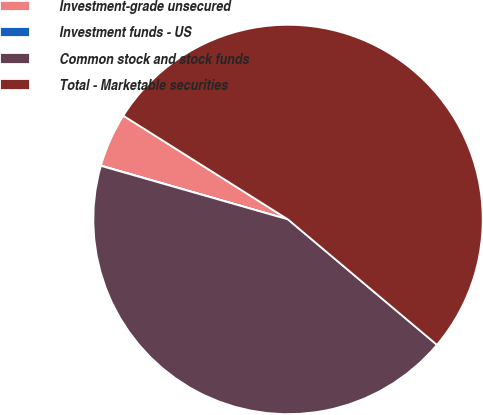<chart> <loc_0><loc_0><loc_500><loc_500><pie_chart><fcel>Investment-grade unsecured<fcel>Investment funds - US<fcel>Common stock and stock funds<fcel>Total - Marketable securities<nl><fcel>4.48%<fcel>0.03%<fcel>43.3%<fcel>52.2%<nl></chart> 